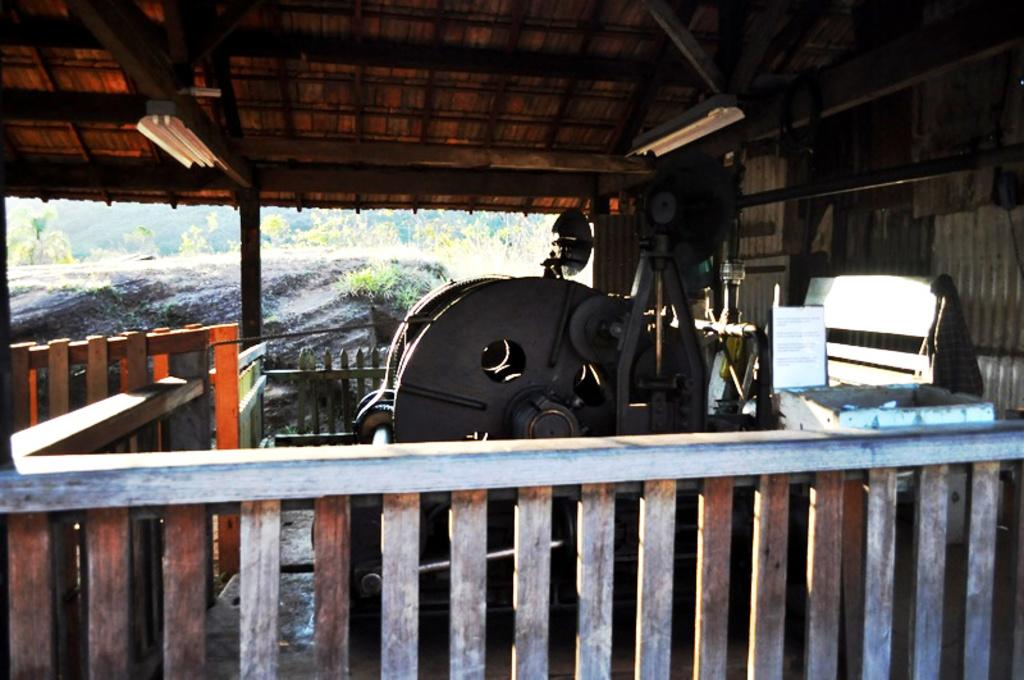What type of natural vegetation can be seen in the background of the image? There are trees in the background of the image. What structure is covering the machine in the image? There is a shed covering the machine in the image. What type of material is used for the railing in the image? The railing in the image is made of wood. How many beds are visible in the image? There are no beds present in the image. What type of lettuce is growing near the machine in the image? There is no lettuce present in the image. 